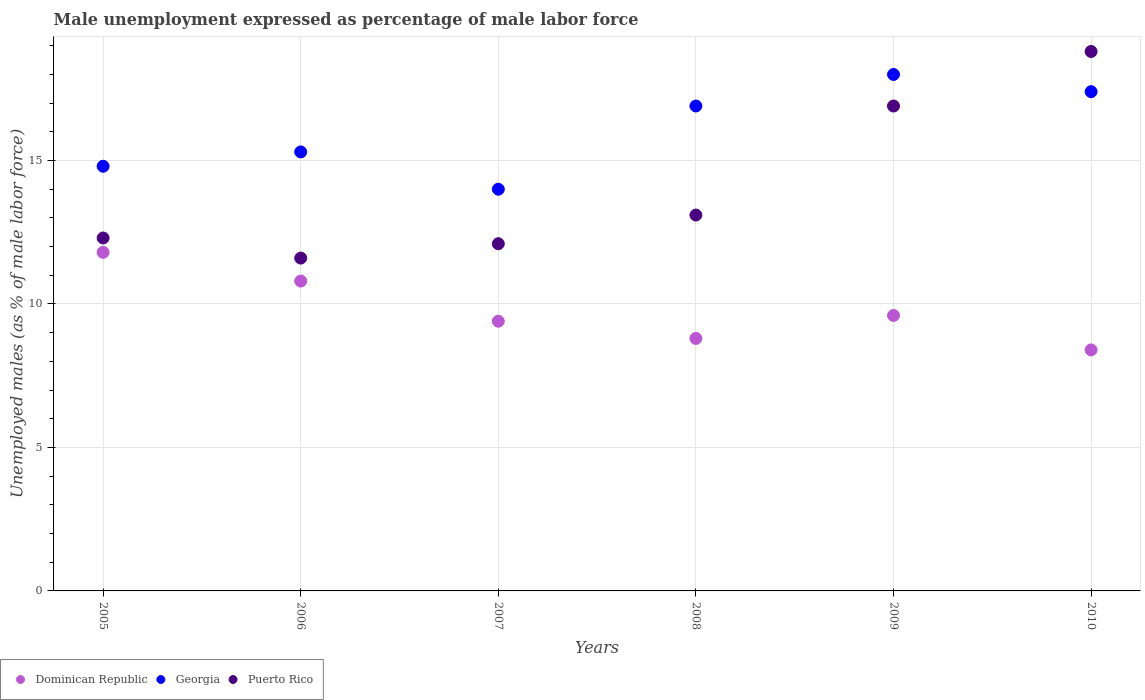What is the unemployment in males in in Dominican Republic in 2009?
Keep it short and to the point. 9.6. Across all years, what is the maximum unemployment in males in in Puerto Rico?
Offer a very short reply. 18.8. Across all years, what is the minimum unemployment in males in in Puerto Rico?
Your response must be concise. 11.6. In which year was the unemployment in males in in Puerto Rico minimum?
Your response must be concise. 2006. What is the total unemployment in males in in Dominican Republic in the graph?
Your answer should be compact. 58.8. What is the difference between the unemployment in males in in Puerto Rico in 2008 and that in 2010?
Offer a very short reply. -5.7. What is the difference between the unemployment in males in in Puerto Rico in 2005 and the unemployment in males in in Georgia in 2007?
Keep it short and to the point. -1.7. What is the average unemployment in males in in Puerto Rico per year?
Give a very brief answer. 14.13. In how many years, is the unemployment in males in in Dominican Republic greater than 13 %?
Make the answer very short. 0. What is the ratio of the unemployment in males in in Georgia in 2008 to that in 2010?
Provide a short and direct response. 0.97. Is the difference between the unemployment in males in in Georgia in 2005 and 2009 greater than the difference between the unemployment in males in in Dominican Republic in 2005 and 2009?
Ensure brevity in your answer.  No. In how many years, is the unemployment in males in in Dominican Republic greater than the average unemployment in males in in Dominican Republic taken over all years?
Ensure brevity in your answer.  2. Is the sum of the unemployment in males in in Puerto Rico in 2006 and 2008 greater than the maximum unemployment in males in in Dominican Republic across all years?
Your response must be concise. Yes. Is it the case that in every year, the sum of the unemployment in males in in Georgia and unemployment in males in in Puerto Rico  is greater than the unemployment in males in in Dominican Republic?
Your answer should be very brief. Yes. How many years are there in the graph?
Ensure brevity in your answer.  6. What is the difference between two consecutive major ticks on the Y-axis?
Give a very brief answer. 5. Are the values on the major ticks of Y-axis written in scientific E-notation?
Provide a short and direct response. No. Does the graph contain any zero values?
Keep it short and to the point. No. Does the graph contain grids?
Your answer should be compact. Yes. What is the title of the graph?
Provide a short and direct response. Male unemployment expressed as percentage of male labor force. Does "Myanmar" appear as one of the legend labels in the graph?
Provide a short and direct response. No. What is the label or title of the X-axis?
Offer a terse response. Years. What is the label or title of the Y-axis?
Your answer should be compact. Unemployed males (as % of male labor force). What is the Unemployed males (as % of male labor force) of Dominican Republic in 2005?
Give a very brief answer. 11.8. What is the Unemployed males (as % of male labor force) of Georgia in 2005?
Provide a short and direct response. 14.8. What is the Unemployed males (as % of male labor force) of Puerto Rico in 2005?
Offer a terse response. 12.3. What is the Unemployed males (as % of male labor force) of Dominican Republic in 2006?
Keep it short and to the point. 10.8. What is the Unemployed males (as % of male labor force) of Georgia in 2006?
Make the answer very short. 15.3. What is the Unemployed males (as % of male labor force) of Puerto Rico in 2006?
Ensure brevity in your answer.  11.6. What is the Unemployed males (as % of male labor force) of Dominican Republic in 2007?
Your answer should be compact. 9.4. What is the Unemployed males (as % of male labor force) in Puerto Rico in 2007?
Ensure brevity in your answer.  12.1. What is the Unemployed males (as % of male labor force) of Dominican Republic in 2008?
Provide a short and direct response. 8.8. What is the Unemployed males (as % of male labor force) in Georgia in 2008?
Offer a very short reply. 16.9. What is the Unemployed males (as % of male labor force) in Puerto Rico in 2008?
Provide a succinct answer. 13.1. What is the Unemployed males (as % of male labor force) of Dominican Republic in 2009?
Provide a short and direct response. 9.6. What is the Unemployed males (as % of male labor force) in Georgia in 2009?
Offer a terse response. 18. What is the Unemployed males (as % of male labor force) in Puerto Rico in 2009?
Your answer should be very brief. 16.9. What is the Unemployed males (as % of male labor force) in Dominican Republic in 2010?
Ensure brevity in your answer.  8.4. What is the Unemployed males (as % of male labor force) of Georgia in 2010?
Provide a succinct answer. 17.4. What is the Unemployed males (as % of male labor force) of Puerto Rico in 2010?
Offer a very short reply. 18.8. Across all years, what is the maximum Unemployed males (as % of male labor force) of Dominican Republic?
Offer a terse response. 11.8. Across all years, what is the maximum Unemployed males (as % of male labor force) in Georgia?
Keep it short and to the point. 18. Across all years, what is the maximum Unemployed males (as % of male labor force) in Puerto Rico?
Provide a short and direct response. 18.8. Across all years, what is the minimum Unemployed males (as % of male labor force) of Dominican Republic?
Your response must be concise. 8.4. Across all years, what is the minimum Unemployed males (as % of male labor force) of Georgia?
Make the answer very short. 14. Across all years, what is the minimum Unemployed males (as % of male labor force) of Puerto Rico?
Give a very brief answer. 11.6. What is the total Unemployed males (as % of male labor force) in Dominican Republic in the graph?
Your answer should be compact. 58.8. What is the total Unemployed males (as % of male labor force) in Georgia in the graph?
Keep it short and to the point. 96.4. What is the total Unemployed males (as % of male labor force) in Puerto Rico in the graph?
Make the answer very short. 84.8. What is the difference between the Unemployed males (as % of male labor force) in Dominican Republic in 2005 and that in 2006?
Ensure brevity in your answer.  1. What is the difference between the Unemployed males (as % of male labor force) in Georgia in 2005 and that in 2006?
Provide a short and direct response. -0.5. What is the difference between the Unemployed males (as % of male labor force) of Dominican Republic in 2005 and that in 2007?
Your answer should be very brief. 2.4. What is the difference between the Unemployed males (as % of male labor force) in Georgia in 2005 and that in 2007?
Your answer should be compact. 0.8. What is the difference between the Unemployed males (as % of male labor force) of Dominican Republic in 2005 and that in 2009?
Give a very brief answer. 2.2. What is the difference between the Unemployed males (as % of male labor force) in Puerto Rico in 2005 and that in 2009?
Your answer should be compact. -4.6. What is the difference between the Unemployed males (as % of male labor force) of Georgia in 2005 and that in 2010?
Offer a very short reply. -2.6. What is the difference between the Unemployed males (as % of male labor force) in Dominican Republic in 2006 and that in 2007?
Give a very brief answer. 1.4. What is the difference between the Unemployed males (as % of male labor force) of Georgia in 2006 and that in 2007?
Your answer should be compact. 1.3. What is the difference between the Unemployed males (as % of male labor force) in Puerto Rico in 2006 and that in 2008?
Give a very brief answer. -1.5. What is the difference between the Unemployed males (as % of male labor force) in Dominican Republic in 2006 and that in 2009?
Give a very brief answer. 1.2. What is the difference between the Unemployed males (as % of male labor force) of Georgia in 2006 and that in 2009?
Ensure brevity in your answer.  -2.7. What is the difference between the Unemployed males (as % of male labor force) in Puerto Rico in 2006 and that in 2010?
Provide a short and direct response. -7.2. What is the difference between the Unemployed males (as % of male labor force) in Puerto Rico in 2007 and that in 2008?
Provide a succinct answer. -1. What is the difference between the Unemployed males (as % of male labor force) in Georgia in 2007 and that in 2010?
Offer a terse response. -3.4. What is the difference between the Unemployed males (as % of male labor force) in Puerto Rico in 2007 and that in 2010?
Your answer should be compact. -6.7. What is the difference between the Unemployed males (as % of male labor force) in Georgia in 2008 and that in 2010?
Give a very brief answer. -0.5. What is the difference between the Unemployed males (as % of male labor force) of Puerto Rico in 2008 and that in 2010?
Offer a very short reply. -5.7. What is the difference between the Unemployed males (as % of male labor force) in Puerto Rico in 2009 and that in 2010?
Your response must be concise. -1.9. What is the difference between the Unemployed males (as % of male labor force) in Dominican Republic in 2005 and the Unemployed males (as % of male labor force) in Georgia in 2006?
Keep it short and to the point. -3.5. What is the difference between the Unemployed males (as % of male labor force) in Dominican Republic in 2005 and the Unemployed males (as % of male labor force) in Puerto Rico in 2006?
Keep it short and to the point. 0.2. What is the difference between the Unemployed males (as % of male labor force) in Dominican Republic in 2005 and the Unemployed males (as % of male labor force) in Georgia in 2007?
Give a very brief answer. -2.2. What is the difference between the Unemployed males (as % of male labor force) in Dominican Republic in 2005 and the Unemployed males (as % of male labor force) in Puerto Rico in 2007?
Offer a very short reply. -0.3. What is the difference between the Unemployed males (as % of male labor force) in Dominican Republic in 2005 and the Unemployed males (as % of male labor force) in Puerto Rico in 2008?
Provide a short and direct response. -1.3. What is the difference between the Unemployed males (as % of male labor force) of Georgia in 2005 and the Unemployed males (as % of male labor force) of Puerto Rico in 2009?
Make the answer very short. -2.1. What is the difference between the Unemployed males (as % of male labor force) of Dominican Republic in 2005 and the Unemployed males (as % of male labor force) of Puerto Rico in 2010?
Ensure brevity in your answer.  -7. What is the difference between the Unemployed males (as % of male labor force) in Georgia in 2005 and the Unemployed males (as % of male labor force) in Puerto Rico in 2010?
Provide a short and direct response. -4. What is the difference between the Unemployed males (as % of male labor force) of Dominican Republic in 2006 and the Unemployed males (as % of male labor force) of Puerto Rico in 2007?
Provide a short and direct response. -1.3. What is the difference between the Unemployed males (as % of male labor force) in Dominican Republic in 2006 and the Unemployed males (as % of male labor force) in Georgia in 2008?
Ensure brevity in your answer.  -6.1. What is the difference between the Unemployed males (as % of male labor force) of Dominican Republic in 2006 and the Unemployed males (as % of male labor force) of Puerto Rico in 2008?
Ensure brevity in your answer.  -2.3. What is the difference between the Unemployed males (as % of male labor force) in Georgia in 2006 and the Unemployed males (as % of male labor force) in Puerto Rico in 2008?
Your answer should be compact. 2.2. What is the difference between the Unemployed males (as % of male labor force) of Dominican Republic in 2006 and the Unemployed males (as % of male labor force) of Georgia in 2010?
Give a very brief answer. -6.6. What is the difference between the Unemployed males (as % of male labor force) in Georgia in 2006 and the Unemployed males (as % of male labor force) in Puerto Rico in 2010?
Ensure brevity in your answer.  -3.5. What is the difference between the Unemployed males (as % of male labor force) in Dominican Republic in 2007 and the Unemployed males (as % of male labor force) in Georgia in 2008?
Your answer should be very brief. -7.5. What is the difference between the Unemployed males (as % of male labor force) of Dominican Republic in 2007 and the Unemployed males (as % of male labor force) of Puerto Rico in 2009?
Make the answer very short. -7.5. What is the difference between the Unemployed males (as % of male labor force) in Georgia in 2007 and the Unemployed males (as % of male labor force) in Puerto Rico in 2009?
Provide a short and direct response. -2.9. What is the difference between the Unemployed males (as % of male labor force) in Dominican Republic in 2007 and the Unemployed males (as % of male labor force) in Georgia in 2010?
Offer a terse response. -8. What is the difference between the Unemployed males (as % of male labor force) in Dominican Republic in 2007 and the Unemployed males (as % of male labor force) in Puerto Rico in 2010?
Keep it short and to the point. -9.4. What is the difference between the Unemployed males (as % of male labor force) in Georgia in 2007 and the Unemployed males (as % of male labor force) in Puerto Rico in 2010?
Keep it short and to the point. -4.8. What is the difference between the Unemployed males (as % of male labor force) in Dominican Republic in 2008 and the Unemployed males (as % of male labor force) in Puerto Rico in 2010?
Offer a very short reply. -10. What is the difference between the Unemployed males (as % of male labor force) of Dominican Republic in 2009 and the Unemployed males (as % of male labor force) of Puerto Rico in 2010?
Your answer should be compact. -9.2. What is the difference between the Unemployed males (as % of male labor force) in Georgia in 2009 and the Unemployed males (as % of male labor force) in Puerto Rico in 2010?
Keep it short and to the point. -0.8. What is the average Unemployed males (as % of male labor force) in Georgia per year?
Provide a succinct answer. 16.07. What is the average Unemployed males (as % of male labor force) of Puerto Rico per year?
Your response must be concise. 14.13. In the year 2005, what is the difference between the Unemployed males (as % of male labor force) in Dominican Republic and Unemployed males (as % of male labor force) in Puerto Rico?
Give a very brief answer. -0.5. In the year 2005, what is the difference between the Unemployed males (as % of male labor force) of Georgia and Unemployed males (as % of male labor force) of Puerto Rico?
Provide a succinct answer. 2.5. In the year 2006, what is the difference between the Unemployed males (as % of male labor force) of Dominican Republic and Unemployed males (as % of male labor force) of Puerto Rico?
Offer a very short reply. -0.8. In the year 2007, what is the difference between the Unemployed males (as % of male labor force) of Georgia and Unemployed males (as % of male labor force) of Puerto Rico?
Ensure brevity in your answer.  1.9. In the year 2008, what is the difference between the Unemployed males (as % of male labor force) in Georgia and Unemployed males (as % of male labor force) in Puerto Rico?
Offer a very short reply. 3.8. In the year 2009, what is the difference between the Unemployed males (as % of male labor force) of Dominican Republic and Unemployed males (as % of male labor force) of Georgia?
Your answer should be compact. -8.4. In the year 2010, what is the difference between the Unemployed males (as % of male labor force) of Dominican Republic and Unemployed males (as % of male labor force) of Puerto Rico?
Provide a succinct answer. -10.4. In the year 2010, what is the difference between the Unemployed males (as % of male labor force) in Georgia and Unemployed males (as % of male labor force) in Puerto Rico?
Your answer should be compact. -1.4. What is the ratio of the Unemployed males (as % of male labor force) in Dominican Republic in 2005 to that in 2006?
Ensure brevity in your answer.  1.09. What is the ratio of the Unemployed males (as % of male labor force) in Georgia in 2005 to that in 2006?
Ensure brevity in your answer.  0.97. What is the ratio of the Unemployed males (as % of male labor force) of Puerto Rico in 2005 to that in 2006?
Provide a short and direct response. 1.06. What is the ratio of the Unemployed males (as % of male labor force) of Dominican Republic in 2005 to that in 2007?
Ensure brevity in your answer.  1.26. What is the ratio of the Unemployed males (as % of male labor force) in Georgia in 2005 to that in 2007?
Provide a succinct answer. 1.06. What is the ratio of the Unemployed males (as % of male labor force) of Puerto Rico in 2005 to that in 2007?
Your response must be concise. 1.02. What is the ratio of the Unemployed males (as % of male labor force) of Dominican Republic in 2005 to that in 2008?
Your answer should be compact. 1.34. What is the ratio of the Unemployed males (as % of male labor force) in Georgia in 2005 to that in 2008?
Offer a terse response. 0.88. What is the ratio of the Unemployed males (as % of male labor force) in Puerto Rico in 2005 to that in 2008?
Give a very brief answer. 0.94. What is the ratio of the Unemployed males (as % of male labor force) in Dominican Republic in 2005 to that in 2009?
Provide a short and direct response. 1.23. What is the ratio of the Unemployed males (as % of male labor force) in Georgia in 2005 to that in 2009?
Your answer should be very brief. 0.82. What is the ratio of the Unemployed males (as % of male labor force) in Puerto Rico in 2005 to that in 2009?
Offer a very short reply. 0.73. What is the ratio of the Unemployed males (as % of male labor force) in Dominican Republic in 2005 to that in 2010?
Make the answer very short. 1.4. What is the ratio of the Unemployed males (as % of male labor force) of Georgia in 2005 to that in 2010?
Keep it short and to the point. 0.85. What is the ratio of the Unemployed males (as % of male labor force) in Puerto Rico in 2005 to that in 2010?
Keep it short and to the point. 0.65. What is the ratio of the Unemployed males (as % of male labor force) of Dominican Republic in 2006 to that in 2007?
Provide a succinct answer. 1.15. What is the ratio of the Unemployed males (as % of male labor force) of Georgia in 2006 to that in 2007?
Your response must be concise. 1.09. What is the ratio of the Unemployed males (as % of male labor force) in Puerto Rico in 2006 to that in 2007?
Provide a short and direct response. 0.96. What is the ratio of the Unemployed males (as % of male labor force) in Dominican Republic in 2006 to that in 2008?
Provide a succinct answer. 1.23. What is the ratio of the Unemployed males (as % of male labor force) in Georgia in 2006 to that in 2008?
Offer a terse response. 0.91. What is the ratio of the Unemployed males (as % of male labor force) of Puerto Rico in 2006 to that in 2008?
Provide a succinct answer. 0.89. What is the ratio of the Unemployed males (as % of male labor force) of Dominican Republic in 2006 to that in 2009?
Provide a short and direct response. 1.12. What is the ratio of the Unemployed males (as % of male labor force) of Georgia in 2006 to that in 2009?
Your response must be concise. 0.85. What is the ratio of the Unemployed males (as % of male labor force) of Puerto Rico in 2006 to that in 2009?
Offer a very short reply. 0.69. What is the ratio of the Unemployed males (as % of male labor force) in Dominican Republic in 2006 to that in 2010?
Your response must be concise. 1.29. What is the ratio of the Unemployed males (as % of male labor force) in Georgia in 2006 to that in 2010?
Keep it short and to the point. 0.88. What is the ratio of the Unemployed males (as % of male labor force) in Puerto Rico in 2006 to that in 2010?
Offer a terse response. 0.62. What is the ratio of the Unemployed males (as % of male labor force) of Dominican Republic in 2007 to that in 2008?
Ensure brevity in your answer.  1.07. What is the ratio of the Unemployed males (as % of male labor force) of Georgia in 2007 to that in 2008?
Offer a terse response. 0.83. What is the ratio of the Unemployed males (as % of male labor force) of Puerto Rico in 2007 to that in 2008?
Your response must be concise. 0.92. What is the ratio of the Unemployed males (as % of male labor force) in Dominican Republic in 2007 to that in 2009?
Keep it short and to the point. 0.98. What is the ratio of the Unemployed males (as % of male labor force) of Puerto Rico in 2007 to that in 2009?
Ensure brevity in your answer.  0.72. What is the ratio of the Unemployed males (as % of male labor force) in Dominican Republic in 2007 to that in 2010?
Ensure brevity in your answer.  1.12. What is the ratio of the Unemployed males (as % of male labor force) of Georgia in 2007 to that in 2010?
Keep it short and to the point. 0.8. What is the ratio of the Unemployed males (as % of male labor force) in Puerto Rico in 2007 to that in 2010?
Provide a succinct answer. 0.64. What is the ratio of the Unemployed males (as % of male labor force) in Georgia in 2008 to that in 2009?
Offer a very short reply. 0.94. What is the ratio of the Unemployed males (as % of male labor force) in Puerto Rico in 2008 to that in 2009?
Your answer should be compact. 0.78. What is the ratio of the Unemployed males (as % of male labor force) in Dominican Republic in 2008 to that in 2010?
Your answer should be very brief. 1.05. What is the ratio of the Unemployed males (as % of male labor force) of Georgia in 2008 to that in 2010?
Keep it short and to the point. 0.97. What is the ratio of the Unemployed males (as % of male labor force) in Puerto Rico in 2008 to that in 2010?
Keep it short and to the point. 0.7. What is the ratio of the Unemployed males (as % of male labor force) in Georgia in 2009 to that in 2010?
Make the answer very short. 1.03. What is the ratio of the Unemployed males (as % of male labor force) in Puerto Rico in 2009 to that in 2010?
Keep it short and to the point. 0.9. What is the difference between the highest and the second highest Unemployed males (as % of male labor force) of Dominican Republic?
Your response must be concise. 1. What is the difference between the highest and the second highest Unemployed males (as % of male labor force) in Puerto Rico?
Keep it short and to the point. 1.9. What is the difference between the highest and the lowest Unemployed males (as % of male labor force) in Georgia?
Give a very brief answer. 4. What is the difference between the highest and the lowest Unemployed males (as % of male labor force) in Puerto Rico?
Your answer should be very brief. 7.2. 